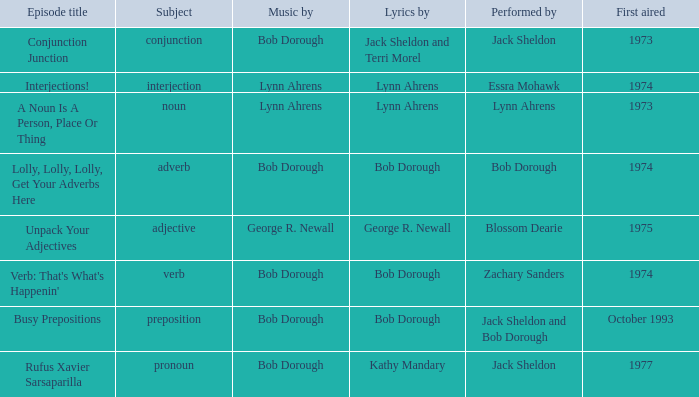When zachary sanders is the performer how many first aired are there? 1.0. 